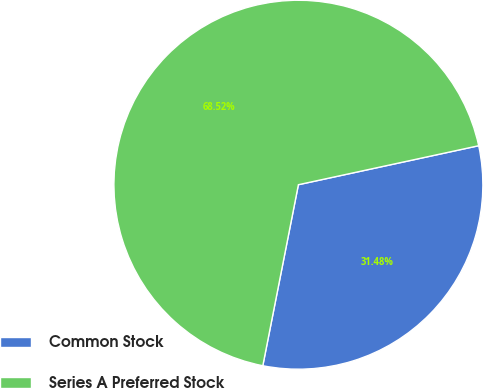Convert chart to OTSL. <chart><loc_0><loc_0><loc_500><loc_500><pie_chart><fcel>Common Stock<fcel>Series A Preferred Stock<nl><fcel>31.48%<fcel>68.52%<nl></chart> 